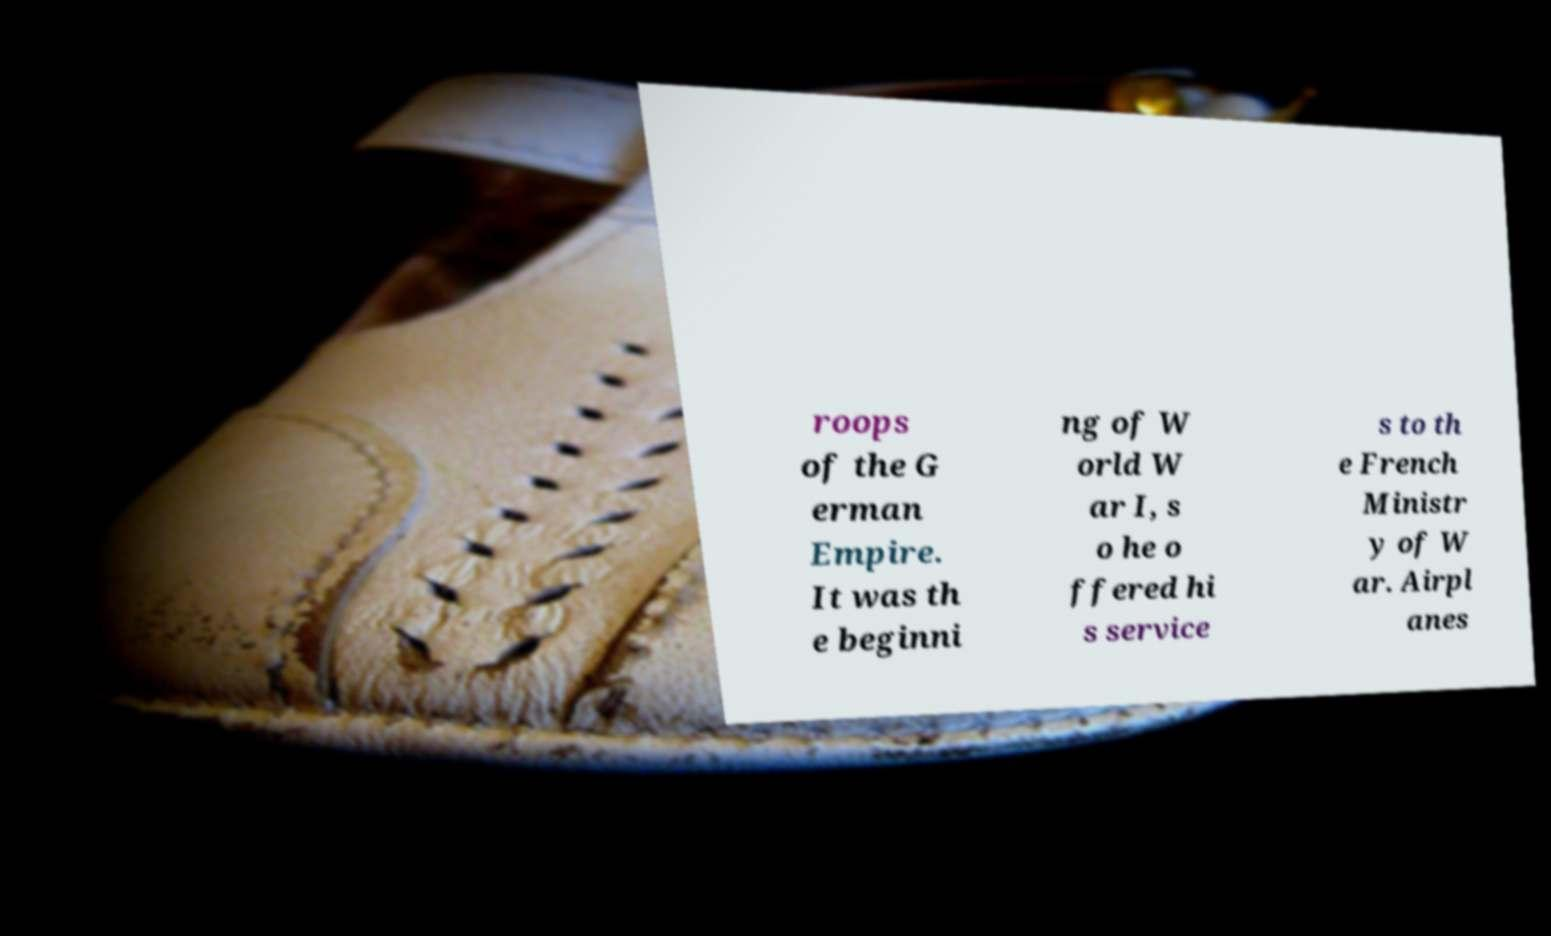Can you read and provide the text displayed in the image?This photo seems to have some interesting text. Can you extract and type it out for me? roops of the G erman Empire. It was th e beginni ng of W orld W ar I, s o he o ffered hi s service s to th e French Ministr y of W ar. Airpl anes 